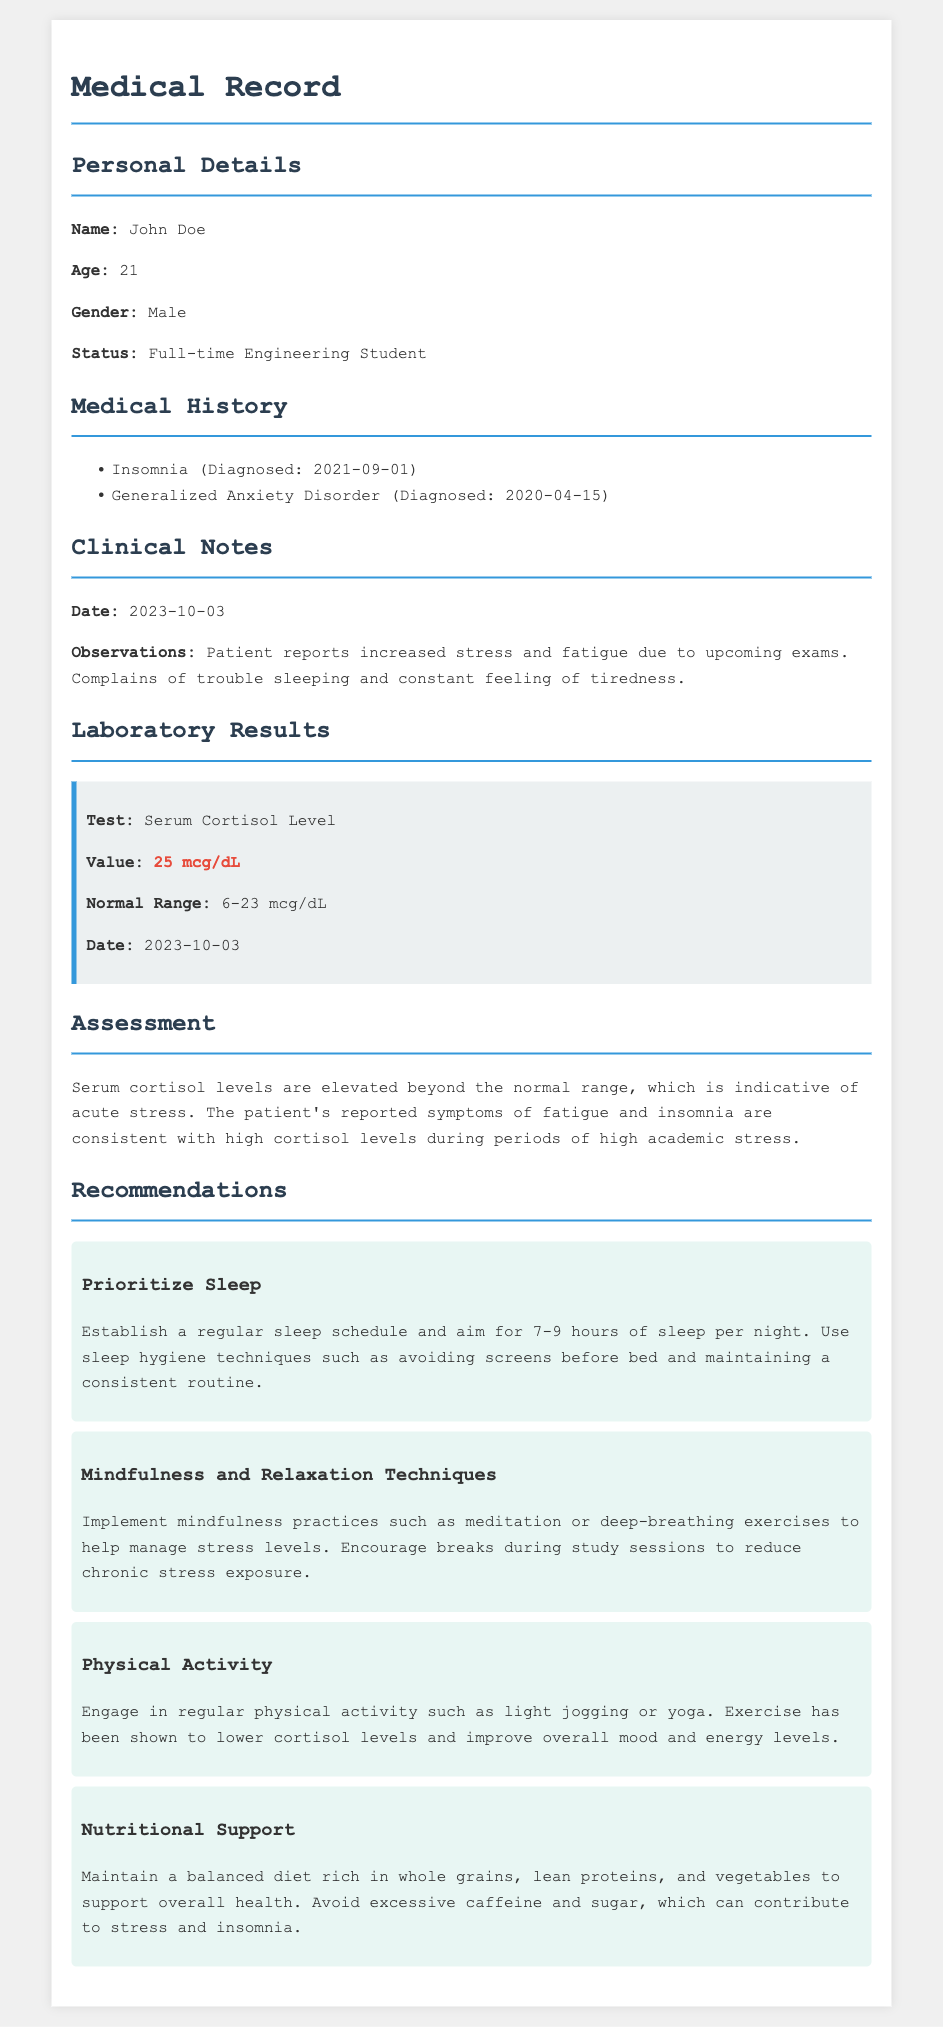What is the patient's name? The patient's name is mentioned in the personal details section of the document.
Answer: John Doe What is the patient's age? The patient's age is provided along with the personal details.
Answer: 21 What is the serum cortisol level? The serum cortisol level is indicated in the laboratory results section.
Answer: 25 mcg/dL What is the normal range for serum cortisol levels? The normal range for cortisol levels is stated in the laboratory results.
Answer: 6-23 mcg/dL What condition was diagnosed on 2021-09-01? The medical history includes various diagnoses, one of which occurred on this date.
Answer: Insomnia What primary symptom does the patient report? The clinical notes describe specific symptoms reported by the patient.
Answer: Increased stress What recommendation is given regarding sleep? The recommendations section provides specific advice on sleep.
Answer: Establish a regular sleep schedule What type of exercise is suggested to lower cortisol levels? Recommendations include physical activities that can help manage cortisol levels.
Answer: Light jogging What is the date of the clinical notes? The date is specified in the clinical notes section.
Answer: 2023-10-03 